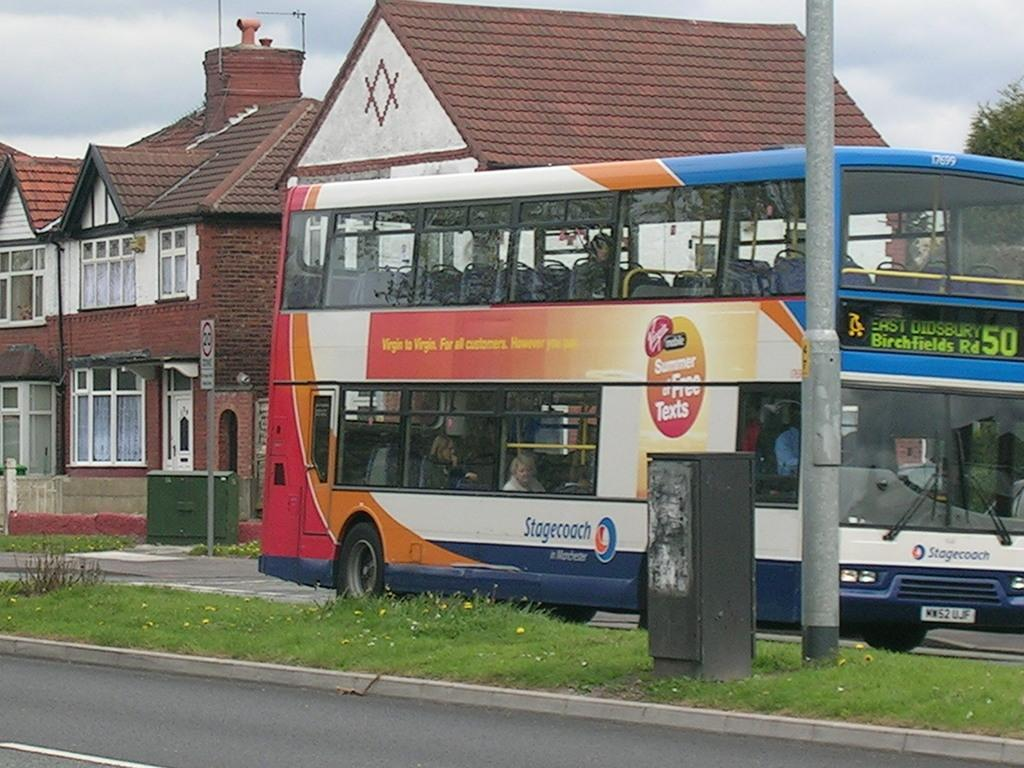<image>
Write a terse but informative summary of the picture. The bus shown travels down the Birchfields Road to reach it's destination. 